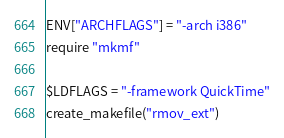Convert code to text. <code><loc_0><loc_0><loc_500><loc_500><_Ruby_>ENV["ARCHFLAGS"] = "-arch i386"
require "mkmf"

$LDFLAGS = "-framework QuickTime"
create_makefile("rmov_ext")
</code> 